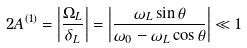Convert formula to latex. <formula><loc_0><loc_0><loc_500><loc_500>2 A ^ { ( 1 ) } = \left | \frac { \Omega _ { L } } { \delta _ { L } } \right | = \left | \frac { \omega _ { L } \sin \theta } { \omega _ { 0 } - \omega _ { L } \cos \theta } \right | \ll 1</formula> 